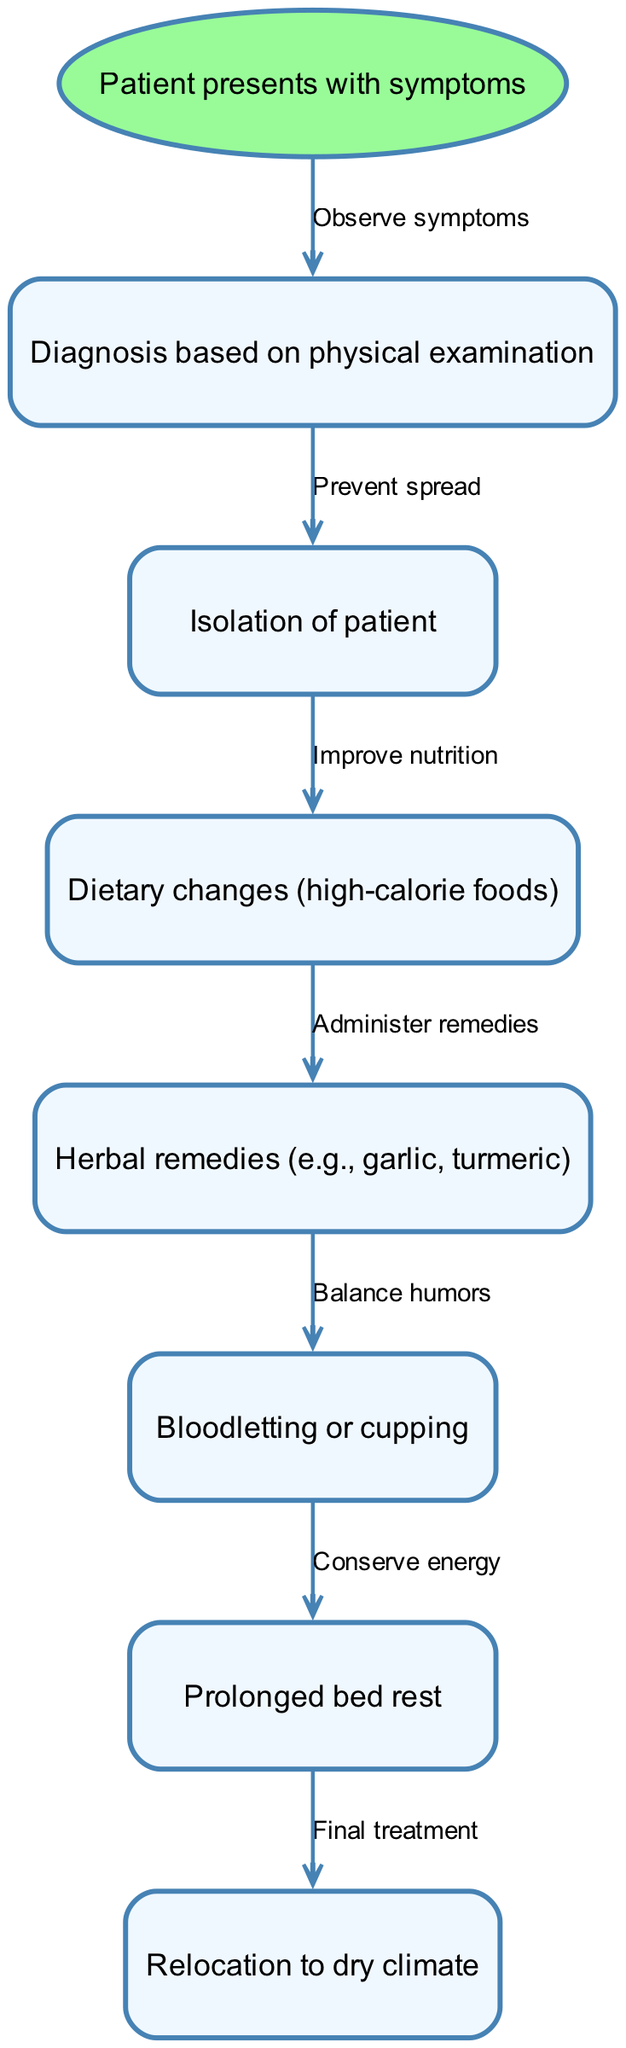What is the starting point of the treatment pathway? The treatment pathway begins with the patient presenting with symptoms, which initiates the diagnosis process.
Answer: Patient presents with symptoms How many nodes are there in the diagram? By counting the nodes listed in the diagram, we have one start point and six subsequent treatment nodes, totaling seven nodes.
Answer: 7 What is the first treatment step after diagnosis? After the diagnosis is made, the patient moves to isolation to prevent the spread of the disease.
Answer: Isolation of patient What is the last treatment step indicated in the pathway? The final treatment step in the pathway is relocating the patient to a dry climate, as shown in the last edge in the diagram.
Answer: Relocation to dry climate What is the relationship between dietary changes and herbal remedies? Dietary changes lead to the administration of herbal remedies as part of the treatment, highlighting an improvement in nutrition's role in support of remedies.
Answer: Administer remedies What treatment follows bloodletting? Following bloodletting, the patient is advised to have prolonged bed rest to conserve energy during the recovery process based on the diagram flow.
Answer: Prolonged bed rest What is the purpose of isolation in this treatment pathway? Isolation serves to prevent the spread of tuberculosis to others while the patient receives treatment, which is indicated in the edge leading to this node.
Answer: Prevent spread What is the rationale behind using herbal remedies after dietary changes? Herbal remedies are administered after dietary changes to further improve the patient's condition through natural medicines, reflecting a holistic approach to treatment.
Answer: Balance humors What is the second treatment step in the pathway? After isolation, the second step is making dietary changes to ensure the patient consumes high-calorie foods to support recovery.
Answer: Dietary changes (high-calorie foods) 